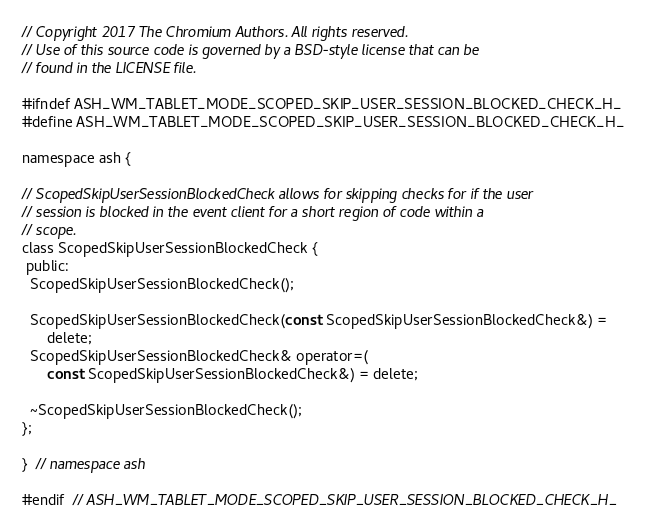Convert code to text. <code><loc_0><loc_0><loc_500><loc_500><_C_>// Copyright 2017 The Chromium Authors. All rights reserved.
// Use of this source code is governed by a BSD-style license that can be
// found in the LICENSE file.

#ifndef ASH_WM_TABLET_MODE_SCOPED_SKIP_USER_SESSION_BLOCKED_CHECK_H_
#define ASH_WM_TABLET_MODE_SCOPED_SKIP_USER_SESSION_BLOCKED_CHECK_H_

namespace ash {

// ScopedSkipUserSessionBlockedCheck allows for skipping checks for if the user
// session is blocked in the event client for a short region of code within a
// scope.
class ScopedSkipUserSessionBlockedCheck {
 public:
  ScopedSkipUserSessionBlockedCheck();

  ScopedSkipUserSessionBlockedCheck(const ScopedSkipUserSessionBlockedCheck&) =
      delete;
  ScopedSkipUserSessionBlockedCheck& operator=(
      const ScopedSkipUserSessionBlockedCheck&) = delete;

  ~ScopedSkipUserSessionBlockedCheck();
};

}  // namespace ash

#endif  // ASH_WM_TABLET_MODE_SCOPED_SKIP_USER_SESSION_BLOCKED_CHECK_H_
</code> 